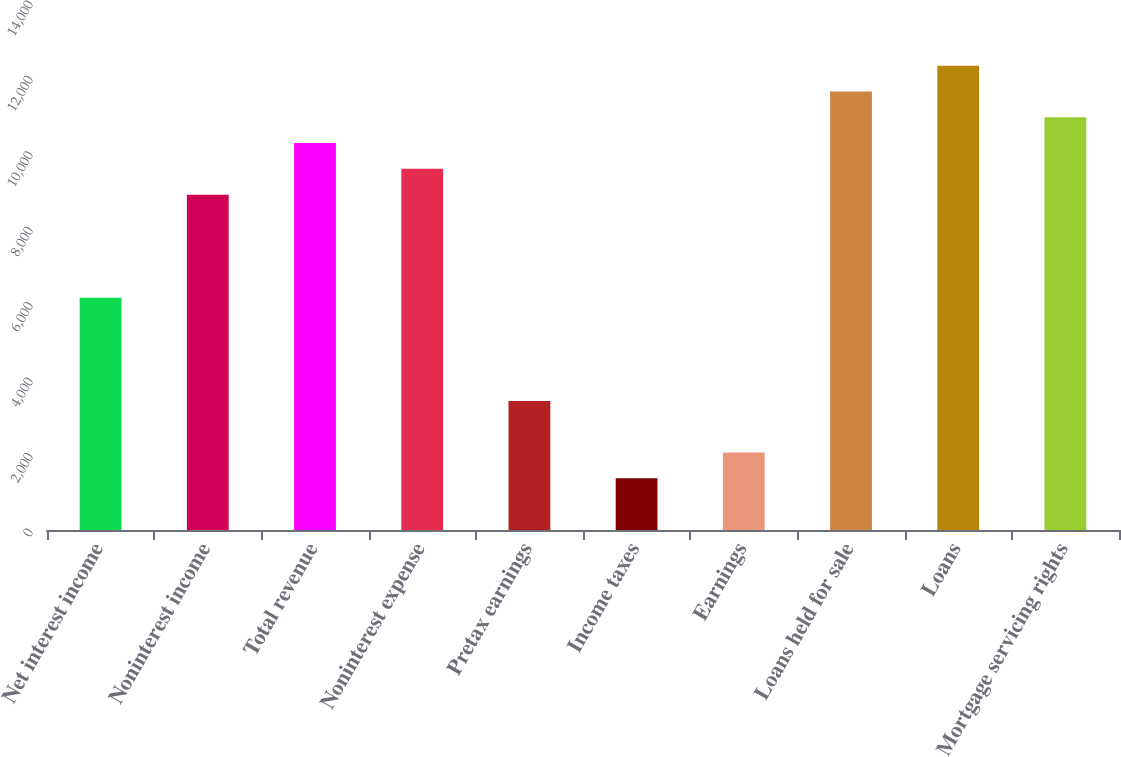Convert chart. <chart><loc_0><loc_0><loc_500><loc_500><bar_chart><fcel>Net interest income<fcel>Noninterest income<fcel>Total revenue<fcel>Noninterest expense<fcel>Pretax earnings<fcel>Income taxes<fcel>Earnings<fcel>Loans held for sale<fcel>Loans<fcel>Mortgage servicing rights<nl><fcel>6156.11<fcel>8891.67<fcel>10259.5<fcel>9575.56<fcel>3420.55<fcel>1368.88<fcel>2052.77<fcel>11627.2<fcel>12311.1<fcel>10943.3<nl></chart> 